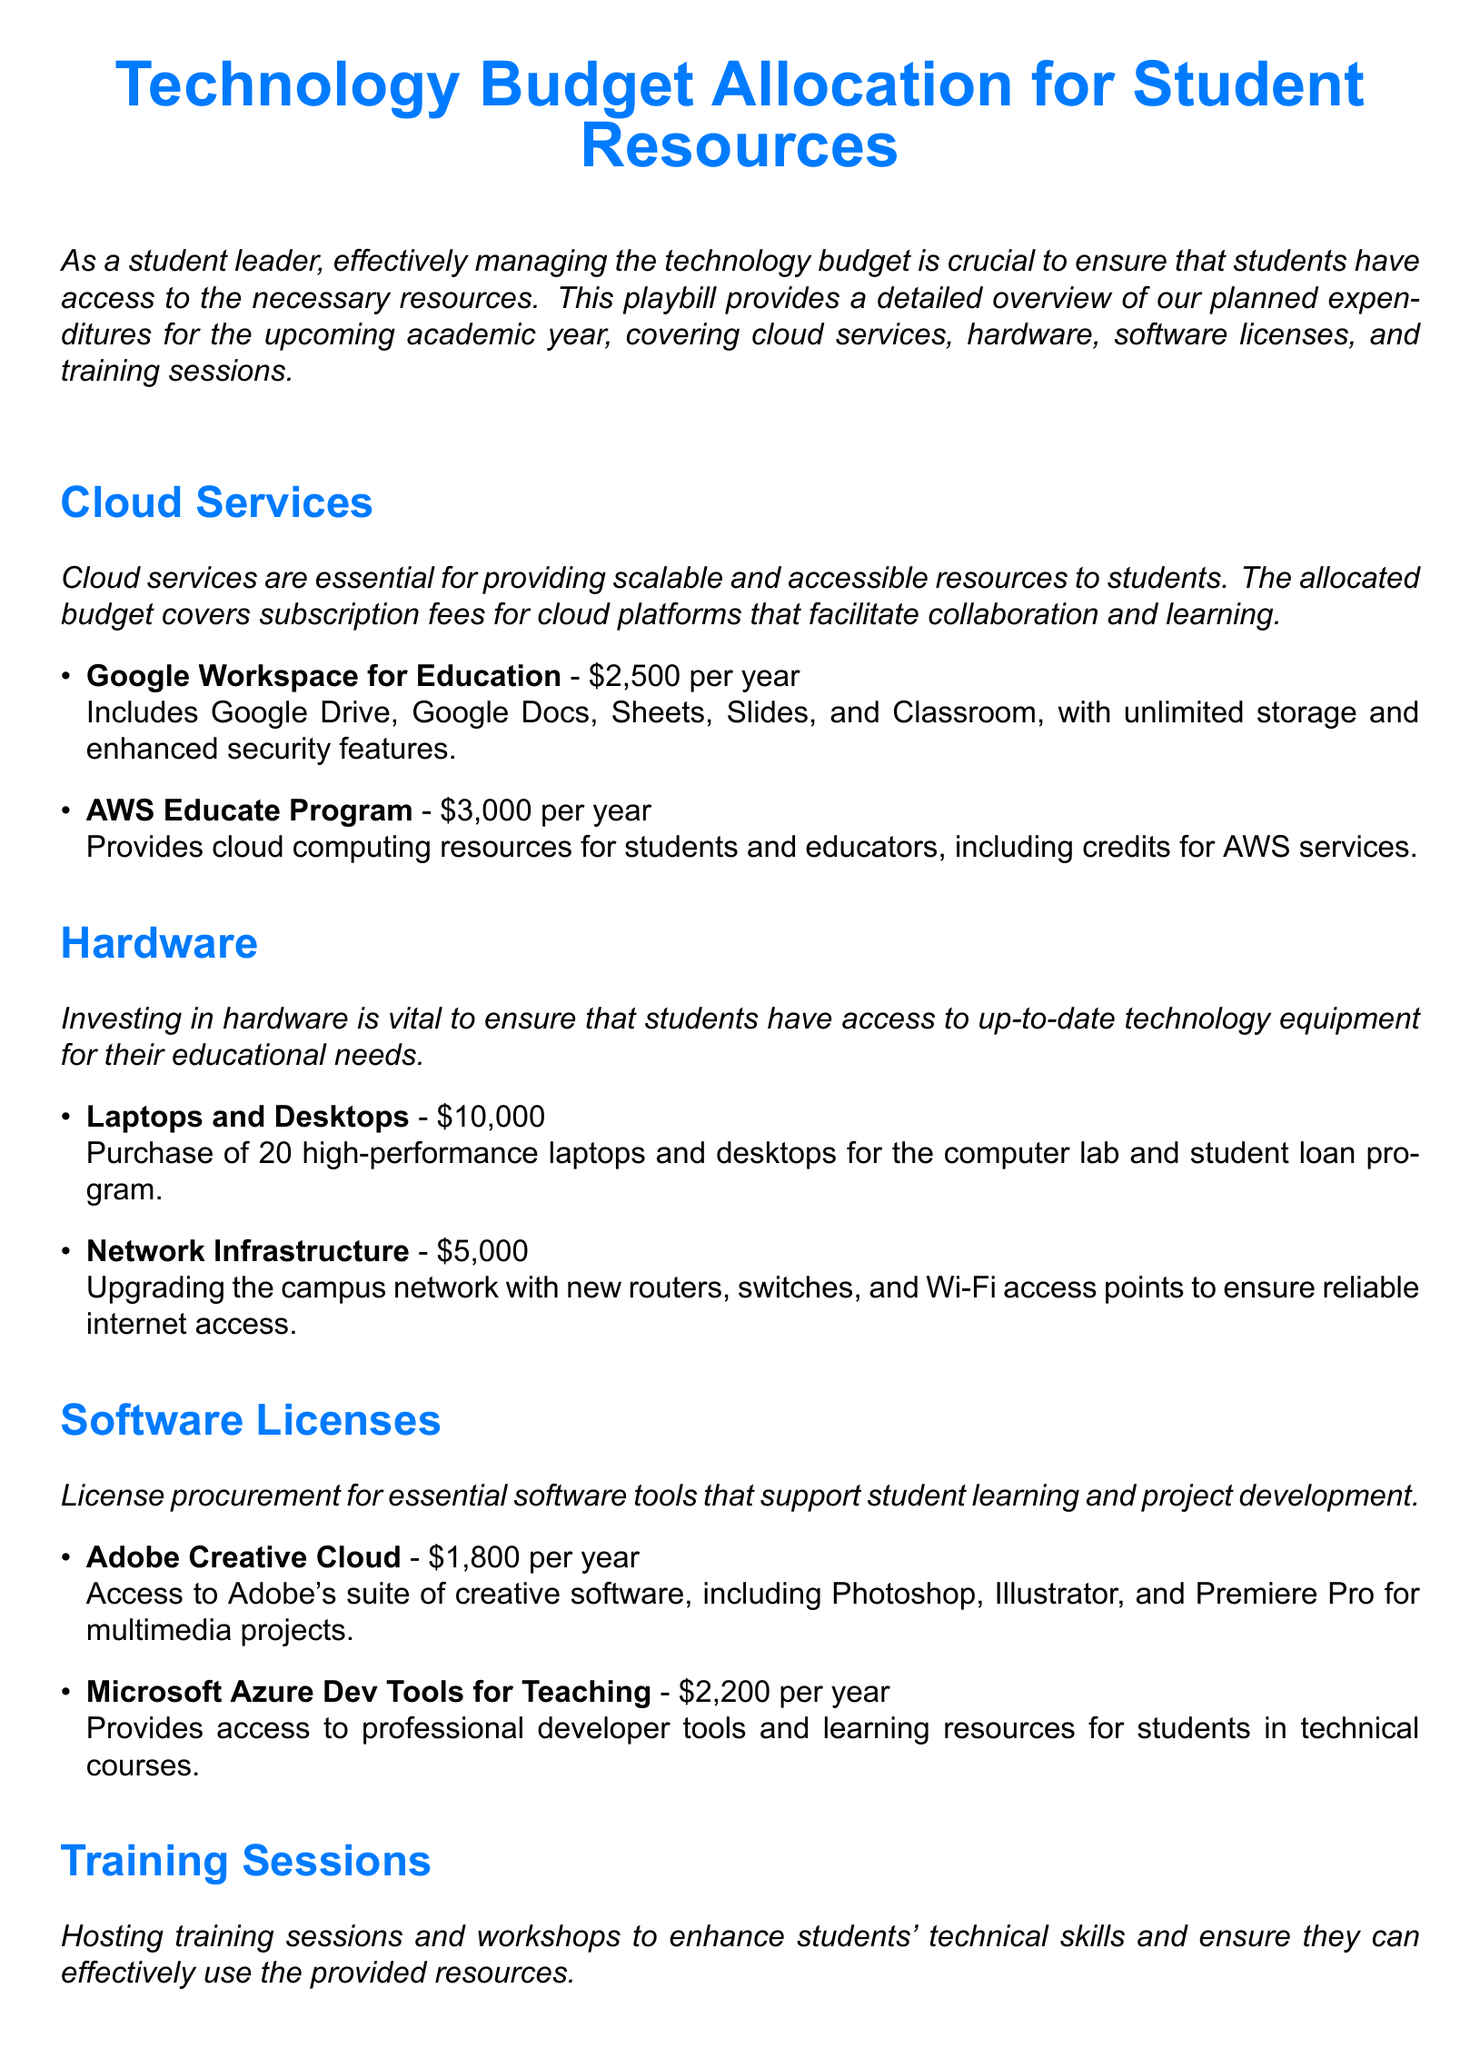what is the total budget allocated for cloud services? The total budget for cloud services is the sum of the allocated amounts for Google Workspace and AWS Educate Program, which is $2500 + $3000 = $5500.
Answer: $5500 how many laptops and desktops are being purchased? The document states that 20 high-performance laptops and desktops are being purchased for the computer lab and student loan program.
Answer: 20 what is the cost of Adobe Creative Cloud? The document specifies that the cost of Adobe Creative Cloud is $1800 per year.
Answer: $1800 what is the budget for training sessions? The budget for training sessions includes the costs for two workshops: $1000 for Introduction to Cloud Computing and $1500 for Advanced Software Development with Python, totaling $2500.
Answer: $2500 what is one of the main purposes of investing in hardware? The document mentions that investing in hardware is vital to ensure that students have access to up-to-date technology equipment for their educational needs.
Answer: Access to up-to-date technology which cloud service provides access to professional developer tools? The specified cloud service in the document providing access to professional developer tools is Microsoft Azure Dev Tools for Teaching.
Answer: Microsoft Azure Dev Tools for Teaching what is the total budget for network infrastructure? The document indicates that the budget for network infrastructure is $5000 for upgrading the campus network.
Answer: $5000 how much is allocated for training in cloud computing? The document states that $1000 is allocated for the training session on Introduction to Cloud Computing.
Answer: $1000 what software suite includes Photoshop and Illustrator? The document identifies that Adobe Creative Cloud includes both Photoshop and Illustrator as part of its software suite.
Answer: Adobe Creative Cloud 